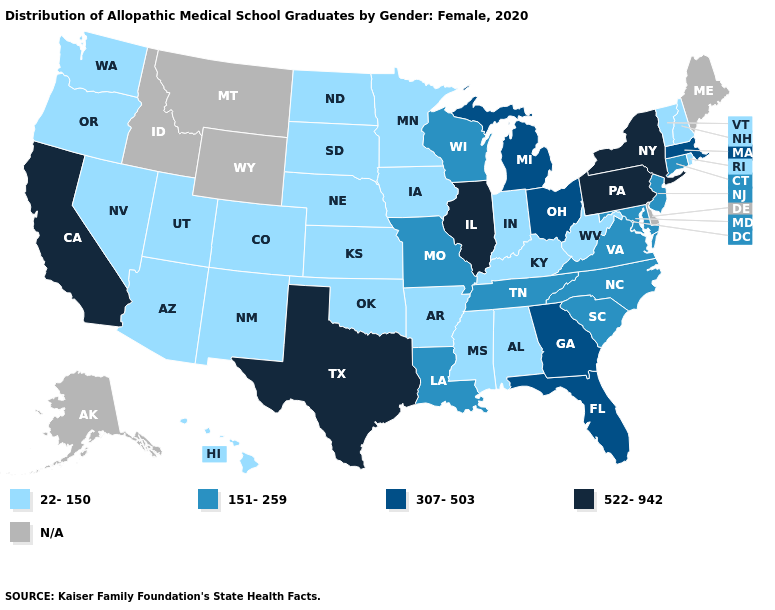What is the lowest value in the MidWest?
Give a very brief answer. 22-150. Does Pennsylvania have the lowest value in the USA?
Answer briefly. No. What is the lowest value in the USA?
Answer briefly. 22-150. What is the highest value in the Northeast ?
Quick response, please. 522-942. Which states have the lowest value in the MidWest?
Answer briefly. Indiana, Iowa, Kansas, Minnesota, Nebraska, North Dakota, South Dakota. Which states have the highest value in the USA?
Answer briefly. California, Illinois, New York, Pennsylvania, Texas. Name the states that have a value in the range 307-503?
Concise answer only. Florida, Georgia, Massachusetts, Michigan, Ohio. Which states have the lowest value in the Northeast?
Answer briefly. New Hampshire, Rhode Island, Vermont. Which states have the lowest value in the USA?
Give a very brief answer. Alabama, Arizona, Arkansas, Colorado, Hawaii, Indiana, Iowa, Kansas, Kentucky, Minnesota, Mississippi, Nebraska, Nevada, New Hampshire, New Mexico, North Dakota, Oklahoma, Oregon, Rhode Island, South Dakota, Utah, Vermont, Washington, West Virginia. Which states hav the highest value in the West?
Answer briefly. California. What is the value of Georgia?
Quick response, please. 307-503. Which states hav the highest value in the Northeast?
Answer briefly. New York, Pennsylvania. Among the states that border Oregon , does Washington have the lowest value?
Keep it brief. Yes. 